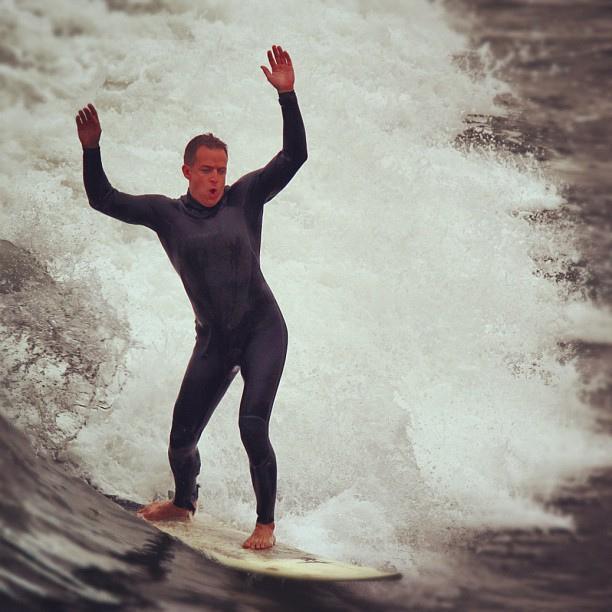How many hands are in the air?
Give a very brief answer. 2. 